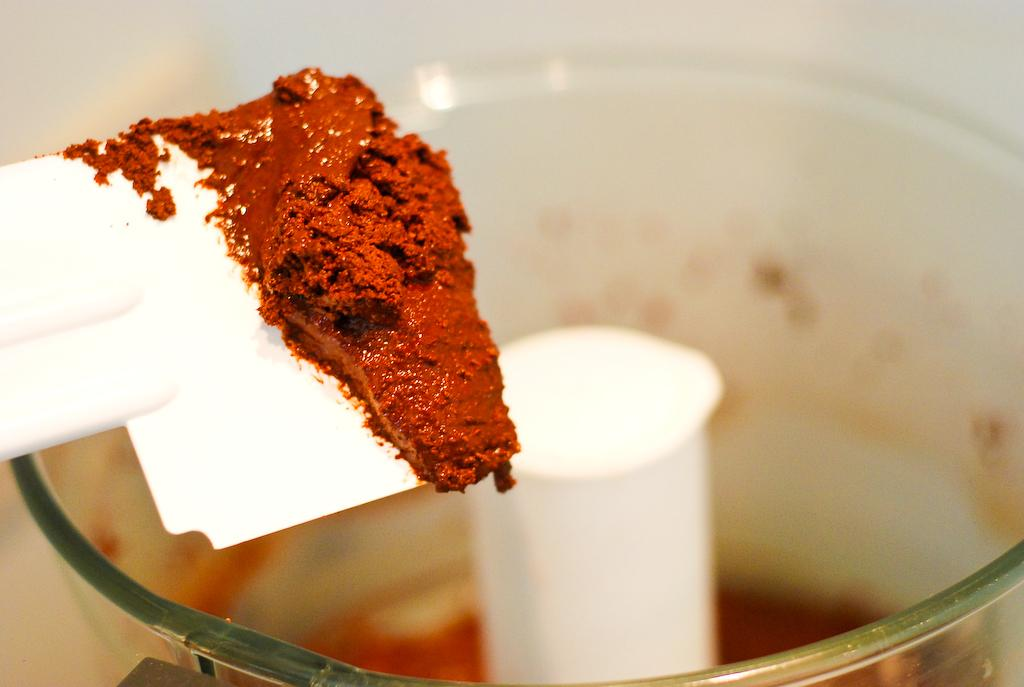What color is the spatula in the image? The spatula in the image is white-colored. What is on the spatula? There is a brown substance on the spatula. Can you describe the background of the image? The background of the image is blurred. What other kitchen appliance can be seen in the image? There is a mixer jar visible in the background of the image. What organization is responsible for the condition of the spatula in the image? There is no organization mentioned or implied in the image, and the condition of the spatula is not relevant to the conversation. 